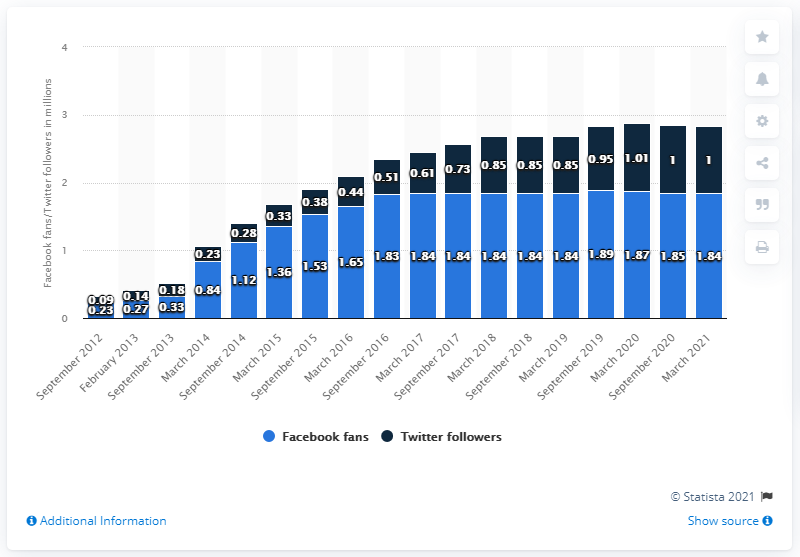Point out several critical features in this image. The average of the three longest navy blue bars is 1.003... In March 2021, the Minnesota Timberwolves basketball team had 1.84 million Facebook followers. In March 2019, the value of Facebook fans was approximately 1.84 million. 